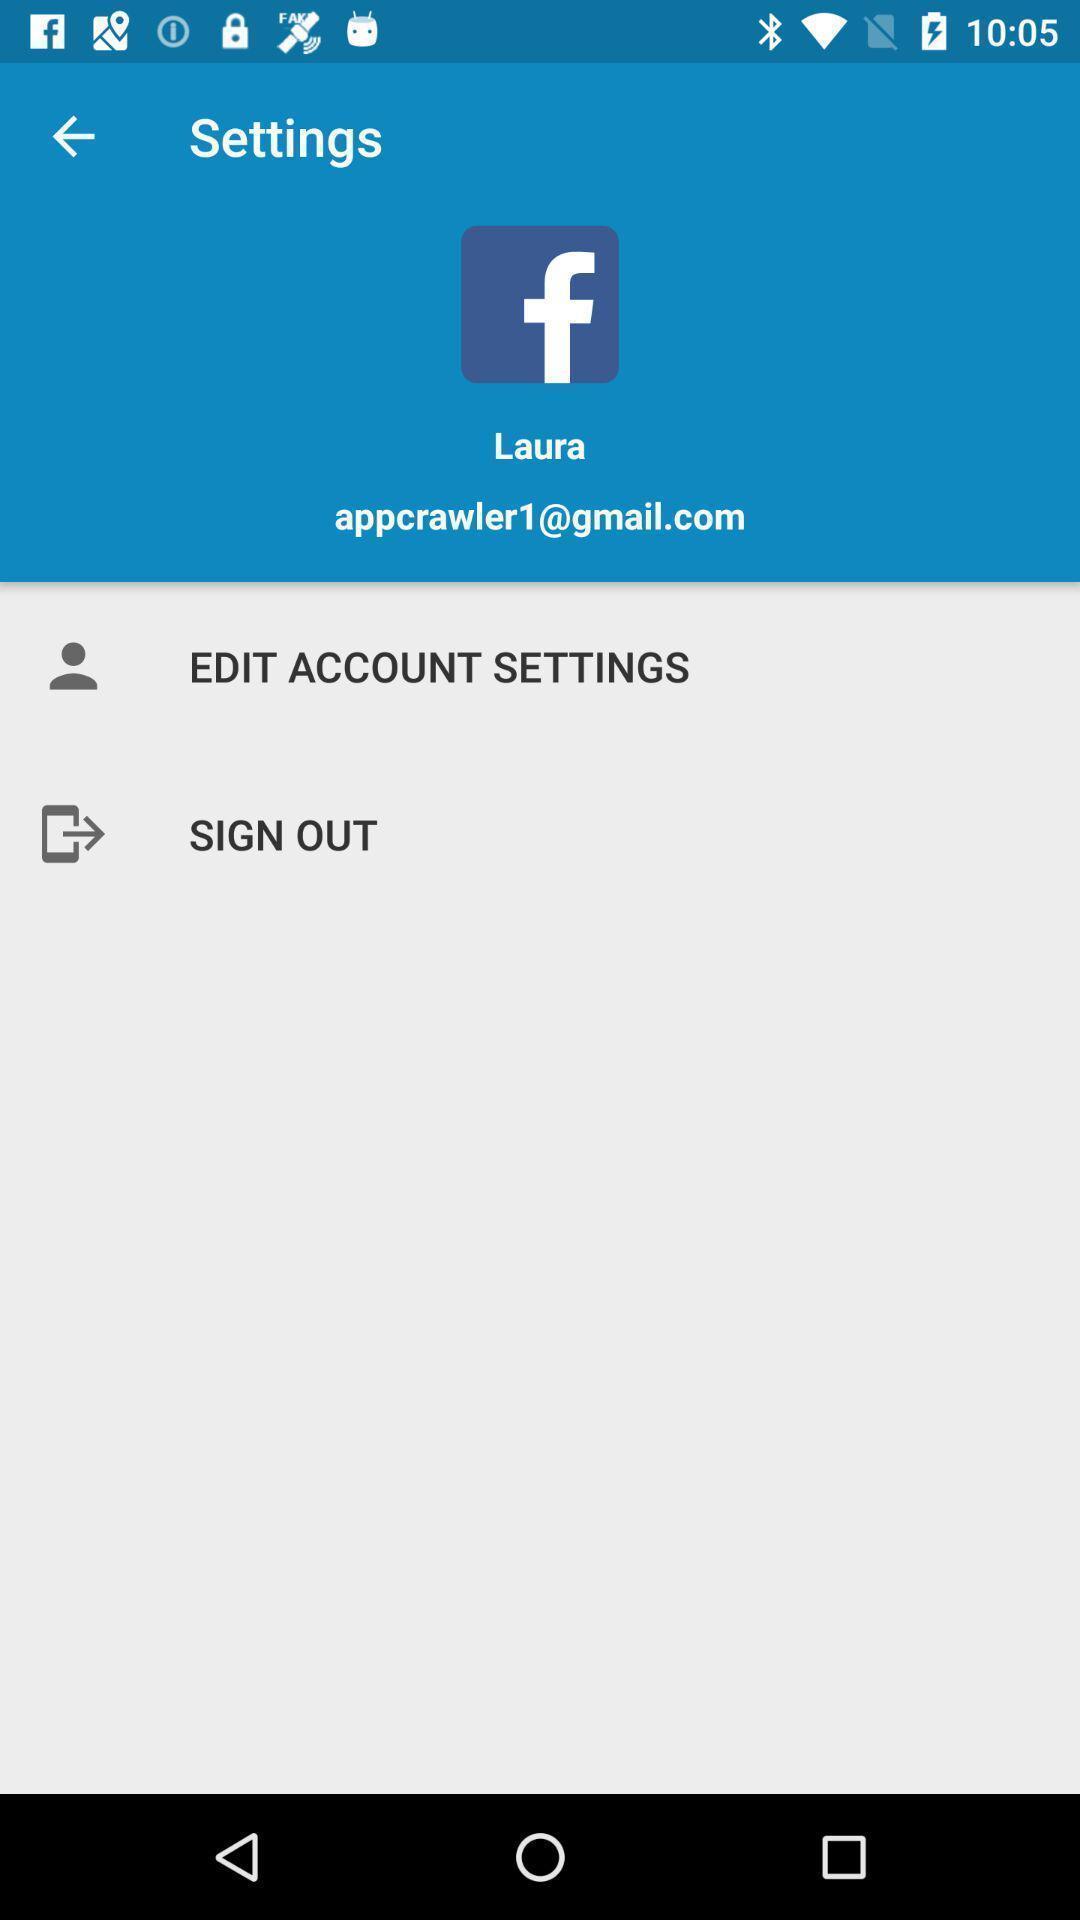Provide a detailed account of this screenshot. Settings page with two more options. 